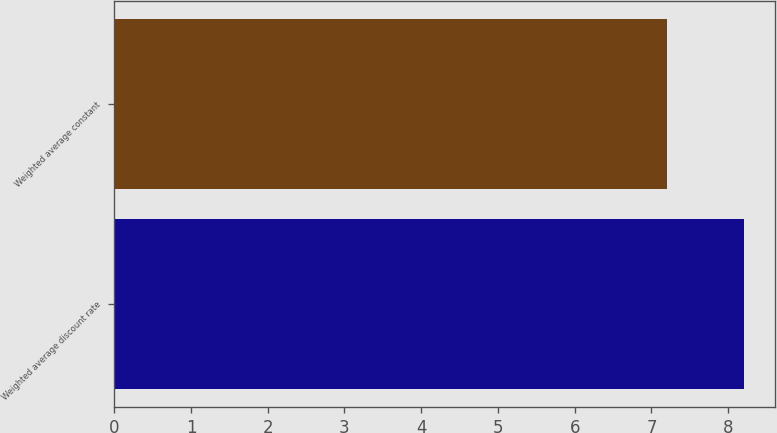Convert chart to OTSL. <chart><loc_0><loc_0><loc_500><loc_500><bar_chart><fcel>Weighted average discount rate<fcel>Weighted average constant<nl><fcel>8.2<fcel>7.2<nl></chart> 